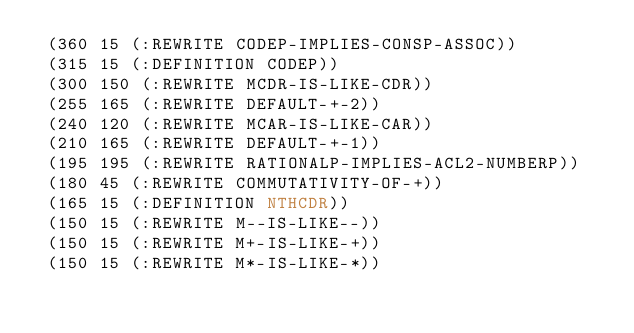<code> <loc_0><loc_0><loc_500><loc_500><_Lisp_> (360 15 (:REWRITE CODEP-IMPLIES-CONSP-ASSOC))
 (315 15 (:DEFINITION CODEP))
 (300 150 (:REWRITE MCDR-IS-LIKE-CDR))
 (255 165 (:REWRITE DEFAULT-+-2))
 (240 120 (:REWRITE MCAR-IS-LIKE-CAR))
 (210 165 (:REWRITE DEFAULT-+-1))
 (195 195 (:REWRITE RATIONALP-IMPLIES-ACL2-NUMBERP))
 (180 45 (:REWRITE COMMUTATIVITY-OF-+))
 (165 15 (:DEFINITION NTHCDR))
 (150 15 (:REWRITE M--IS-LIKE--))
 (150 15 (:REWRITE M+-IS-LIKE-+))
 (150 15 (:REWRITE M*-IS-LIKE-*))</code> 